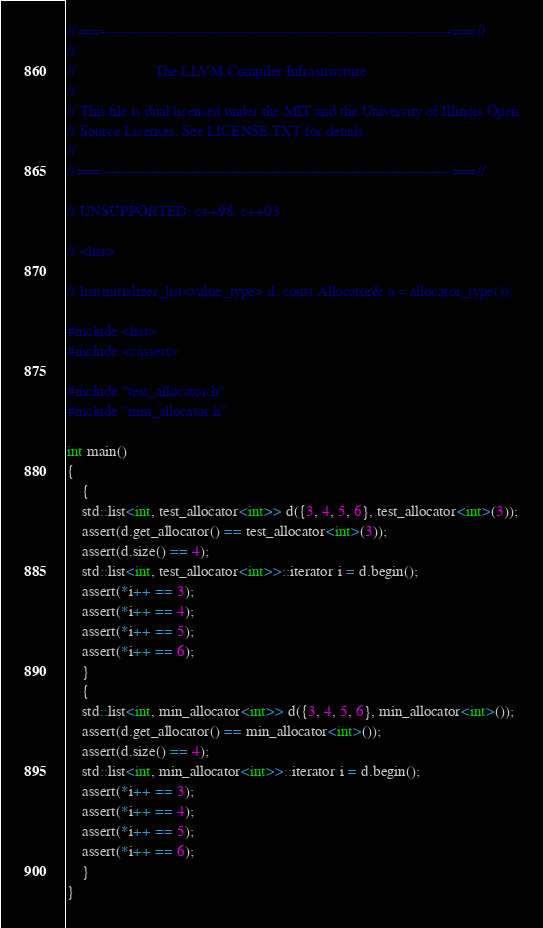<code> <loc_0><loc_0><loc_500><loc_500><_C++_>//===----------------------------------------------------------------------===//
//
//                     The LLVM Compiler Infrastructure
//
// This file is dual licensed under the MIT and the University of Illinois Open
// Source Licenses. See LICENSE.TXT for details.
//
//===----------------------------------------------------------------------===//

// UNSUPPORTED: c++98, c++03

// <list>

// list(initializer_list<value_type> il, const Allocator& a = allocator_type());

#include <list>
#include <cassert>

#include "test_allocator.h"
#include "min_allocator.h"

int main()
{
    {
    std::list<int, test_allocator<int>> d({3, 4, 5, 6}, test_allocator<int>(3));
    assert(d.get_allocator() == test_allocator<int>(3));
    assert(d.size() == 4);
    std::list<int, test_allocator<int>>::iterator i = d.begin();
    assert(*i++ == 3);
    assert(*i++ == 4);
    assert(*i++ == 5);
    assert(*i++ == 6);
    }
    {
    std::list<int, min_allocator<int>> d({3, 4, 5, 6}, min_allocator<int>());
    assert(d.get_allocator() == min_allocator<int>());
    assert(d.size() == 4);
    std::list<int, min_allocator<int>>::iterator i = d.begin();
    assert(*i++ == 3);
    assert(*i++ == 4);
    assert(*i++ == 5);
    assert(*i++ == 6);
    }
}
</code> 